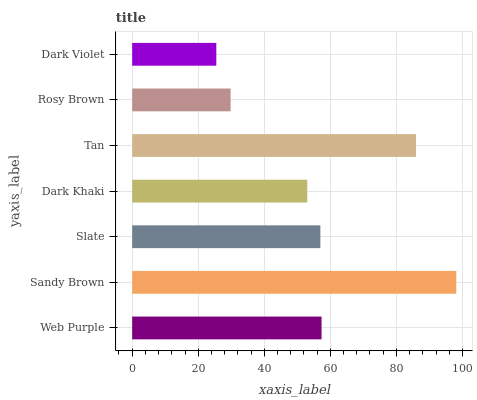Is Dark Violet the minimum?
Answer yes or no. Yes. Is Sandy Brown the maximum?
Answer yes or no. Yes. Is Slate the minimum?
Answer yes or no. No. Is Slate the maximum?
Answer yes or no. No. Is Sandy Brown greater than Slate?
Answer yes or no. Yes. Is Slate less than Sandy Brown?
Answer yes or no. Yes. Is Slate greater than Sandy Brown?
Answer yes or no. No. Is Sandy Brown less than Slate?
Answer yes or no. No. Is Slate the high median?
Answer yes or no. Yes. Is Slate the low median?
Answer yes or no. Yes. Is Sandy Brown the high median?
Answer yes or no. No. Is Dark Violet the low median?
Answer yes or no. No. 